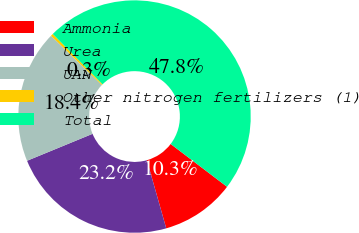Convert chart to OTSL. <chart><loc_0><loc_0><loc_500><loc_500><pie_chart><fcel>Ammonia<fcel>Urea<fcel>UAN<fcel>Other nitrogen fertilizers (1)<fcel>Total<nl><fcel>10.27%<fcel>23.19%<fcel>18.45%<fcel>0.34%<fcel>47.76%<nl></chart> 